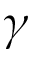<formula> <loc_0><loc_0><loc_500><loc_500>\gamma</formula> 